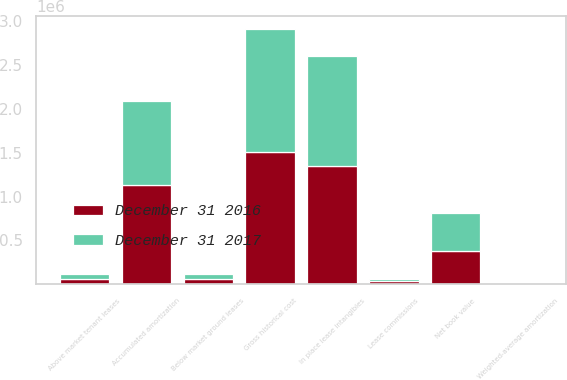Convert chart to OTSL. <chart><loc_0><loc_0><loc_500><loc_500><stacked_bar_chart><ecel><fcel>In place lease intangibles<fcel>Above market tenant leases<fcel>Below market ground leases<fcel>Lease commissions<fcel>Gross historical cost<fcel>Accumulated amortization<fcel>Net book value<fcel>Weighted-average amortization<nl><fcel>December 31 2016<fcel>1.35214e+06<fcel>58443<fcel>58784<fcel>33105<fcel>1.50247e+06<fcel>1.12544e+06<fcel>377034<fcel>15.1<nl><fcel>December 31 2017<fcel>1.25214e+06<fcel>61700<fcel>61628<fcel>27413<fcel>1.40288e+06<fcel>966714<fcel>436170<fcel>13.7<nl></chart> 